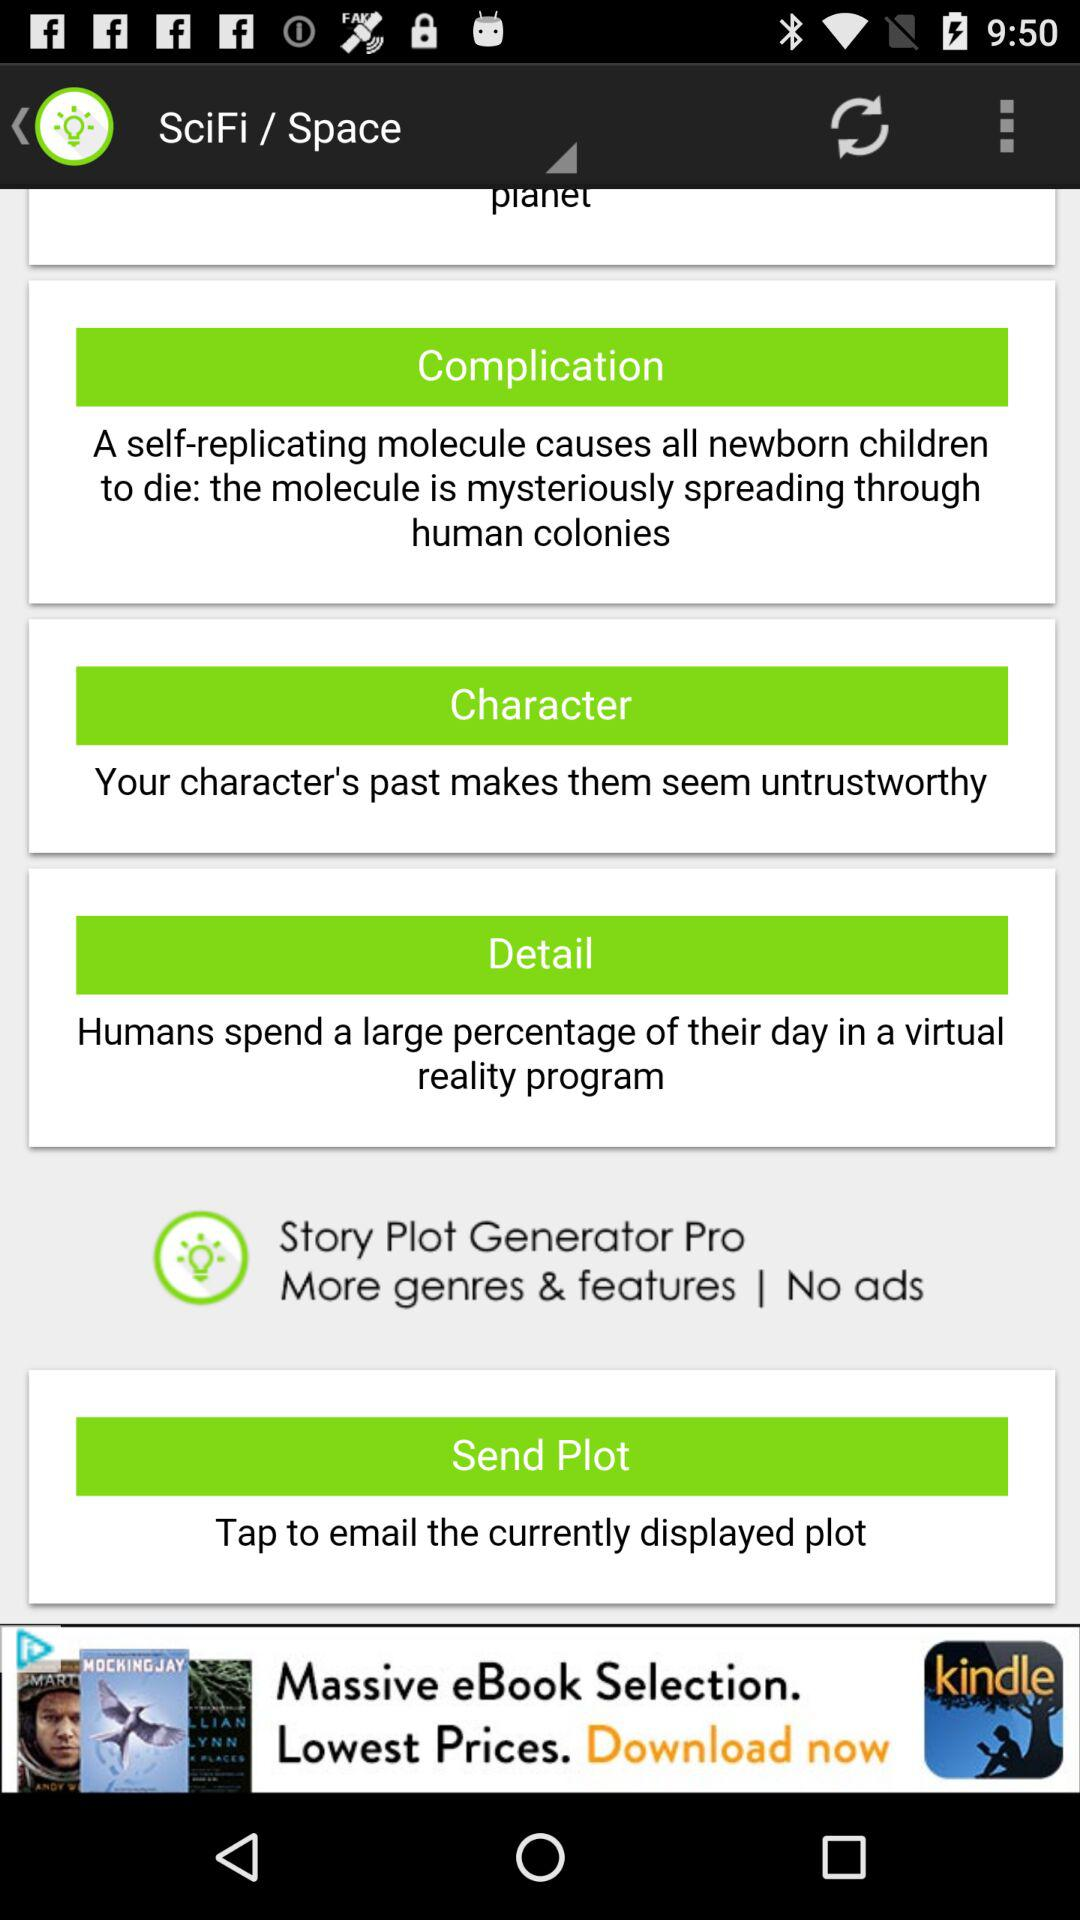What molecule causes newborn children to die? The causes of newborn child mortality are self-replicating molecules. 